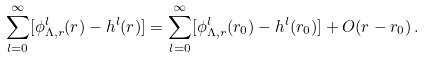Convert formula to latex. <formula><loc_0><loc_0><loc_500><loc_500>\sum _ { l = 0 } ^ { \infty } [ \phi _ { \Lambda , r } ^ { l } ( r ) - h ^ { l } ( r ) ] = \sum _ { l = 0 } ^ { \infty } [ \phi _ { \Lambda , r } ^ { l } ( r _ { 0 } ) - h ^ { l } ( r _ { 0 } ) ] + O ( r - r _ { 0 } ) \, .</formula> 